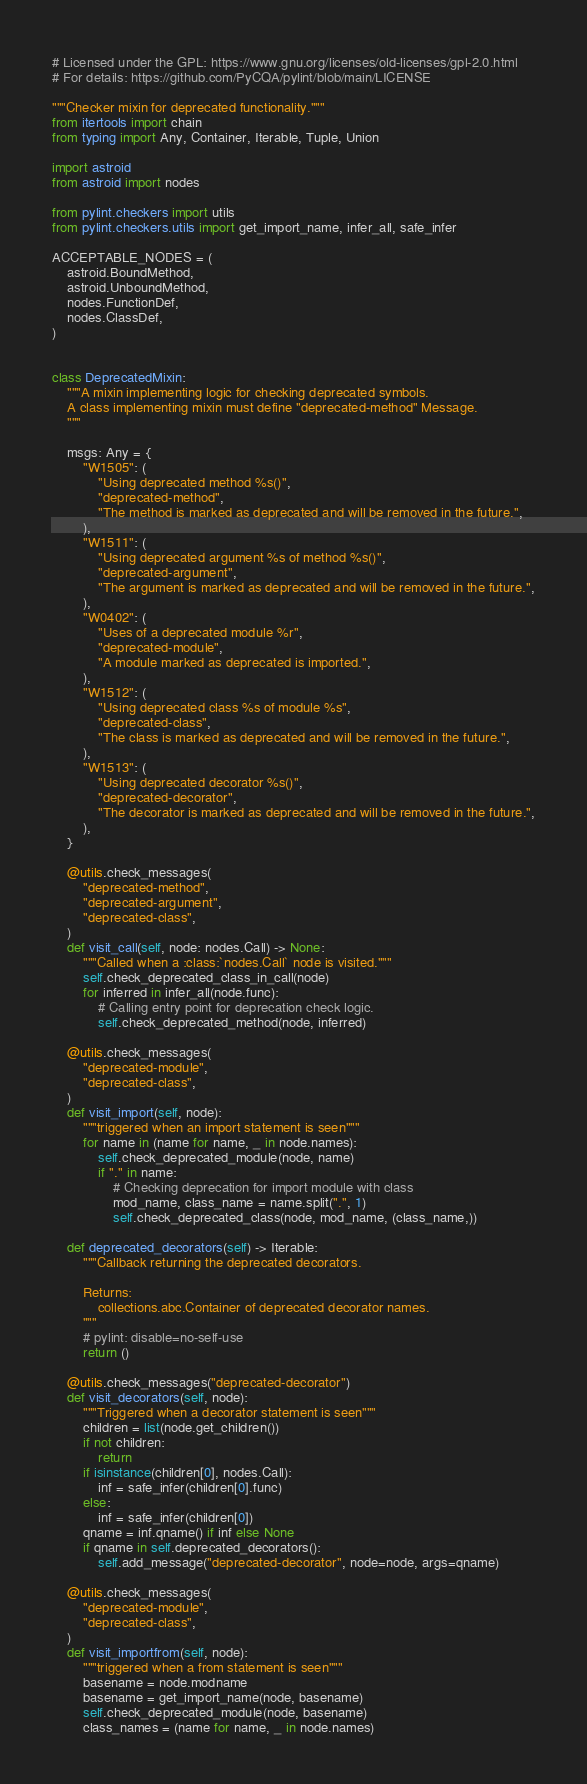<code> <loc_0><loc_0><loc_500><loc_500><_Python_># Licensed under the GPL: https://www.gnu.org/licenses/old-licenses/gpl-2.0.html
# For details: https://github.com/PyCQA/pylint/blob/main/LICENSE

"""Checker mixin for deprecated functionality."""
from itertools import chain
from typing import Any, Container, Iterable, Tuple, Union

import astroid
from astroid import nodes

from pylint.checkers import utils
from pylint.checkers.utils import get_import_name, infer_all, safe_infer

ACCEPTABLE_NODES = (
    astroid.BoundMethod,
    astroid.UnboundMethod,
    nodes.FunctionDef,
    nodes.ClassDef,
)


class DeprecatedMixin:
    """A mixin implementing logic for checking deprecated symbols.
    A class implementing mixin must define "deprecated-method" Message.
    """

    msgs: Any = {
        "W1505": (
            "Using deprecated method %s()",
            "deprecated-method",
            "The method is marked as deprecated and will be removed in the future.",
        ),
        "W1511": (
            "Using deprecated argument %s of method %s()",
            "deprecated-argument",
            "The argument is marked as deprecated and will be removed in the future.",
        ),
        "W0402": (
            "Uses of a deprecated module %r",
            "deprecated-module",
            "A module marked as deprecated is imported.",
        ),
        "W1512": (
            "Using deprecated class %s of module %s",
            "deprecated-class",
            "The class is marked as deprecated and will be removed in the future.",
        ),
        "W1513": (
            "Using deprecated decorator %s()",
            "deprecated-decorator",
            "The decorator is marked as deprecated and will be removed in the future.",
        ),
    }

    @utils.check_messages(
        "deprecated-method",
        "deprecated-argument",
        "deprecated-class",
    )
    def visit_call(self, node: nodes.Call) -> None:
        """Called when a :class:`nodes.Call` node is visited."""
        self.check_deprecated_class_in_call(node)
        for inferred in infer_all(node.func):
            # Calling entry point for deprecation check logic.
            self.check_deprecated_method(node, inferred)

    @utils.check_messages(
        "deprecated-module",
        "deprecated-class",
    )
    def visit_import(self, node):
        """triggered when an import statement is seen"""
        for name in (name for name, _ in node.names):
            self.check_deprecated_module(node, name)
            if "." in name:
                # Checking deprecation for import module with class
                mod_name, class_name = name.split(".", 1)
                self.check_deprecated_class(node, mod_name, (class_name,))

    def deprecated_decorators(self) -> Iterable:
        """Callback returning the deprecated decorators.

        Returns:
            collections.abc.Container of deprecated decorator names.
        """
        # pylint: disable=no-self-use
        return ()

    @utils.check_messages("deprecated-decorator")
    def visit_decorators(self, node):
        """Triggered when a decorator statement is seen"""
        children = list(node.get_children())
        if not children:
            return
        if isinstance(children[0], nodes.Call):
            inf = safe_infer(children[0].func)
        else:
            inf = safe_infer(children[0])
        qname = inf.qname() if inf else None
        if qname in self.deprecated_decorators():
            self.add_message("deprecated-decorator", node=node, args=qname)

    @utils.check_messages(
        "deprecated-module",
        "deprecated-class",
    )
    def visit_importfrom(self, node):
        """triggered when a from statement is seen"""
        basename = node.modname
        basename = get_import_name(node, basename)
        self.check_deprecated_module(node, basename)
        class_names = (name for name, _ in node.names)</code> 